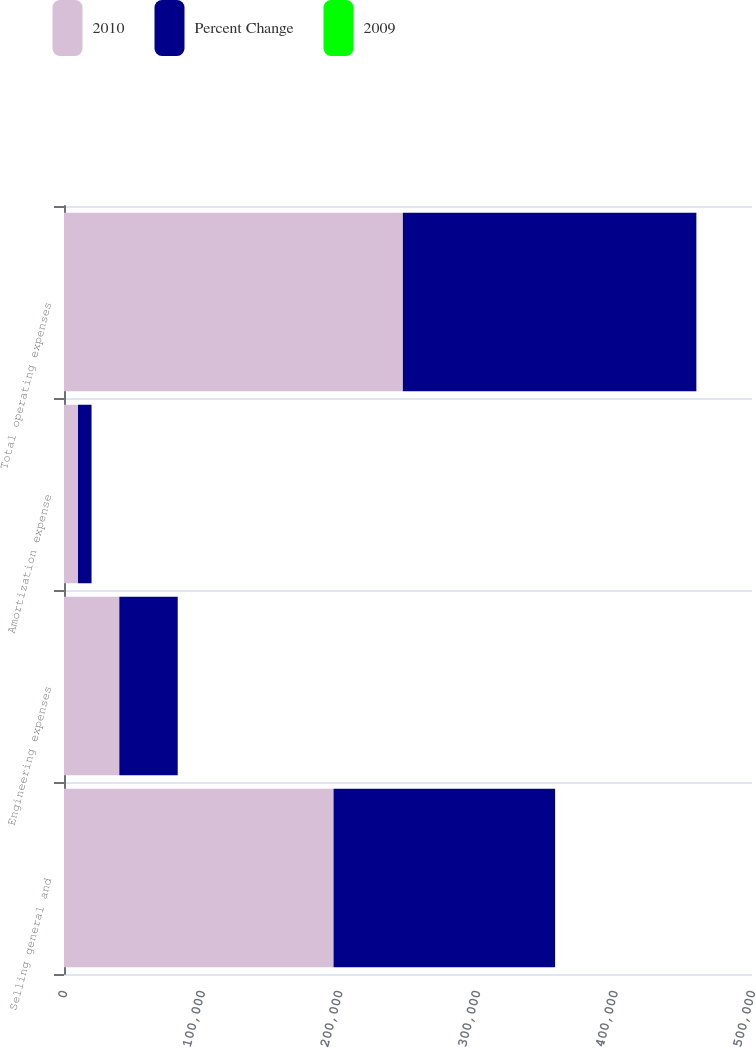Convert chart to OTSL. <chart><loc_0><loc_0><loc_500><loc_500><stacked_bar_chart><ecel><fcel>Selling general and<fcel>Engineering expenses<fcel>Amortization expense<fcel>Total operating expenses<nl><fcel>2010<fcel>195892<fcel>40203<fcel>10173<fcel>246268<nl><fcel>Percent Change<fcel>160998<fcel>42447<fcel>9849<fcel>213294<nl><fcel>2009<fcel>21.7<fcel>5.3<fcel>3.3<fcel>15.5<nl></chart> 